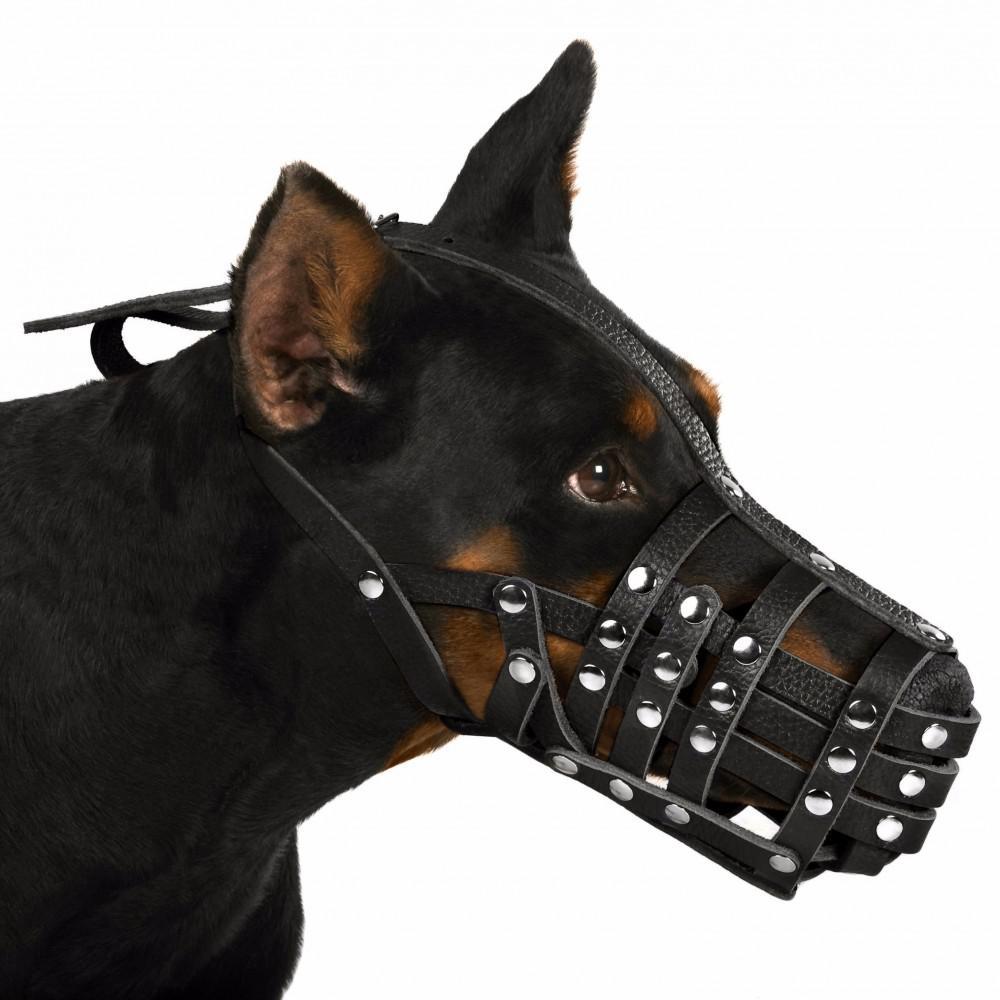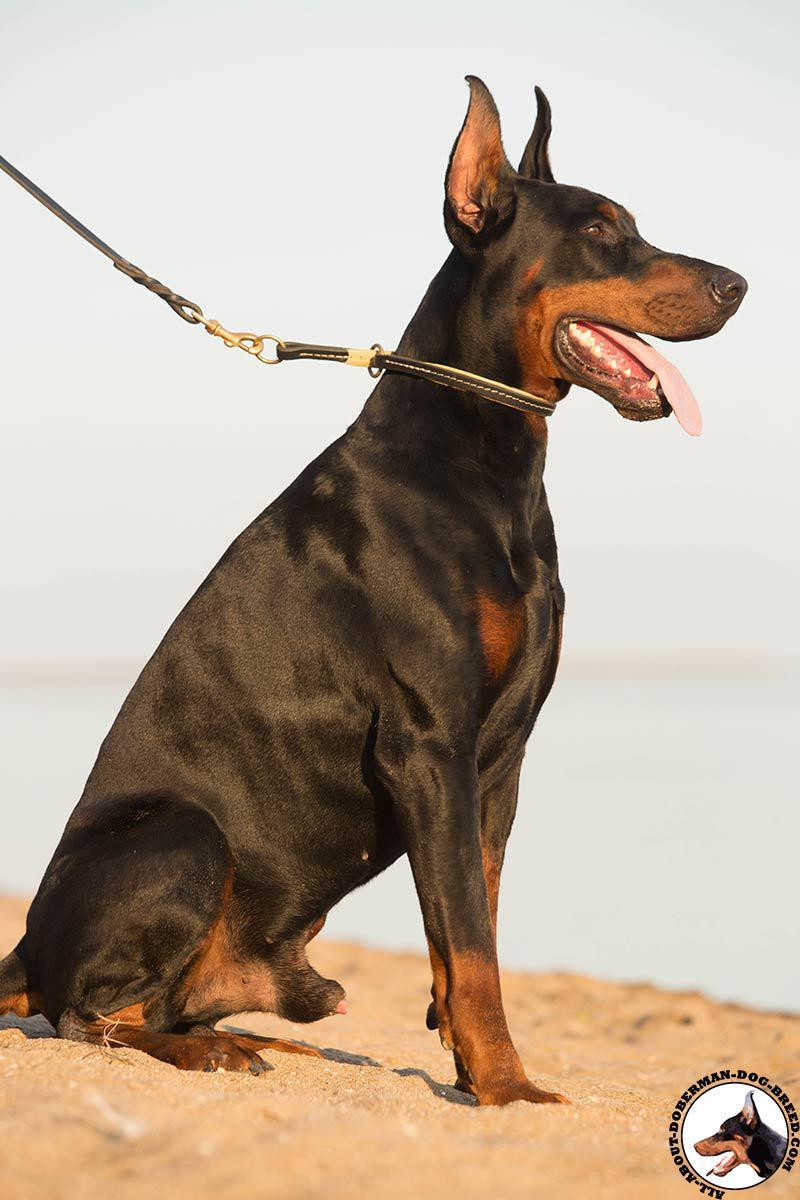The first image is the image on the left, the second image is the image on the right. Examine the images to the left and right. Is the description "One of the dogs is wearing a muzzle." accurate? Answer yes or no. Yes. 